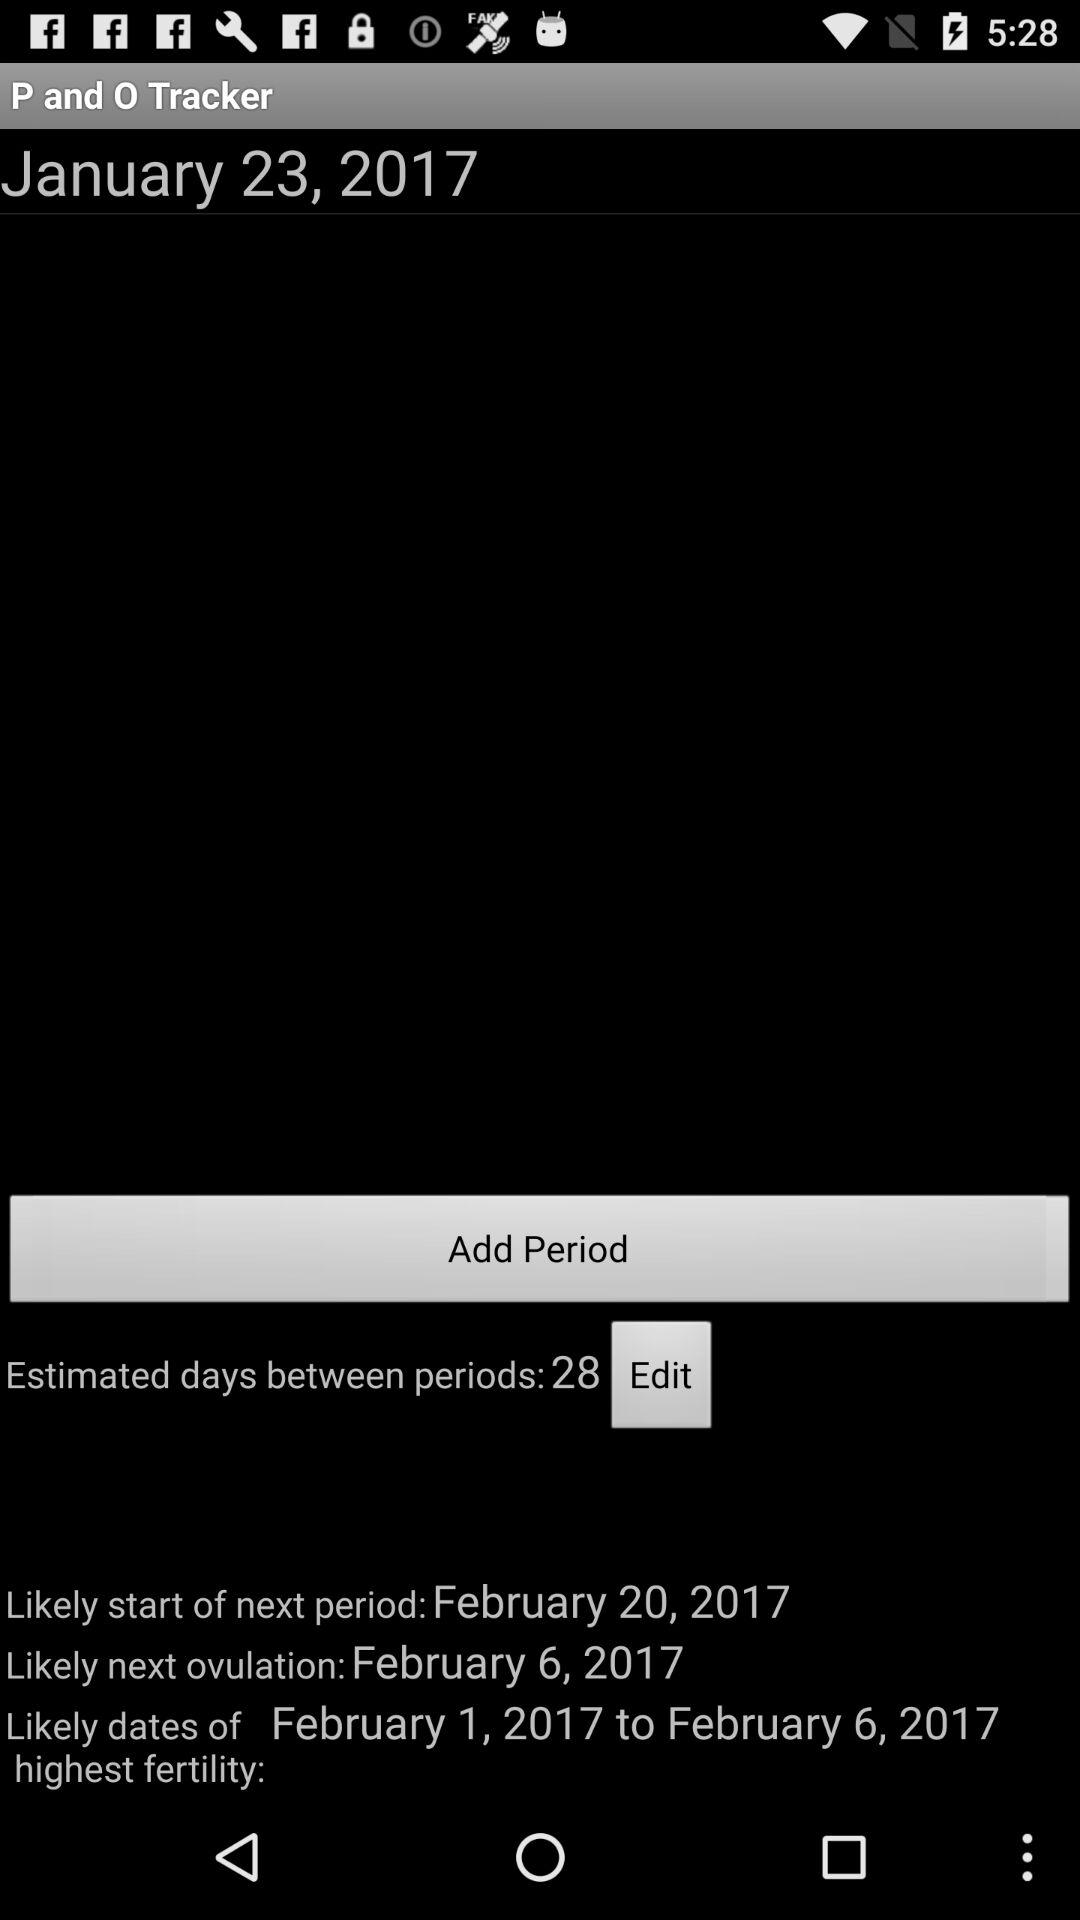How many days apart are the last two periods?
Answer the question using a single word or phrase. 28 